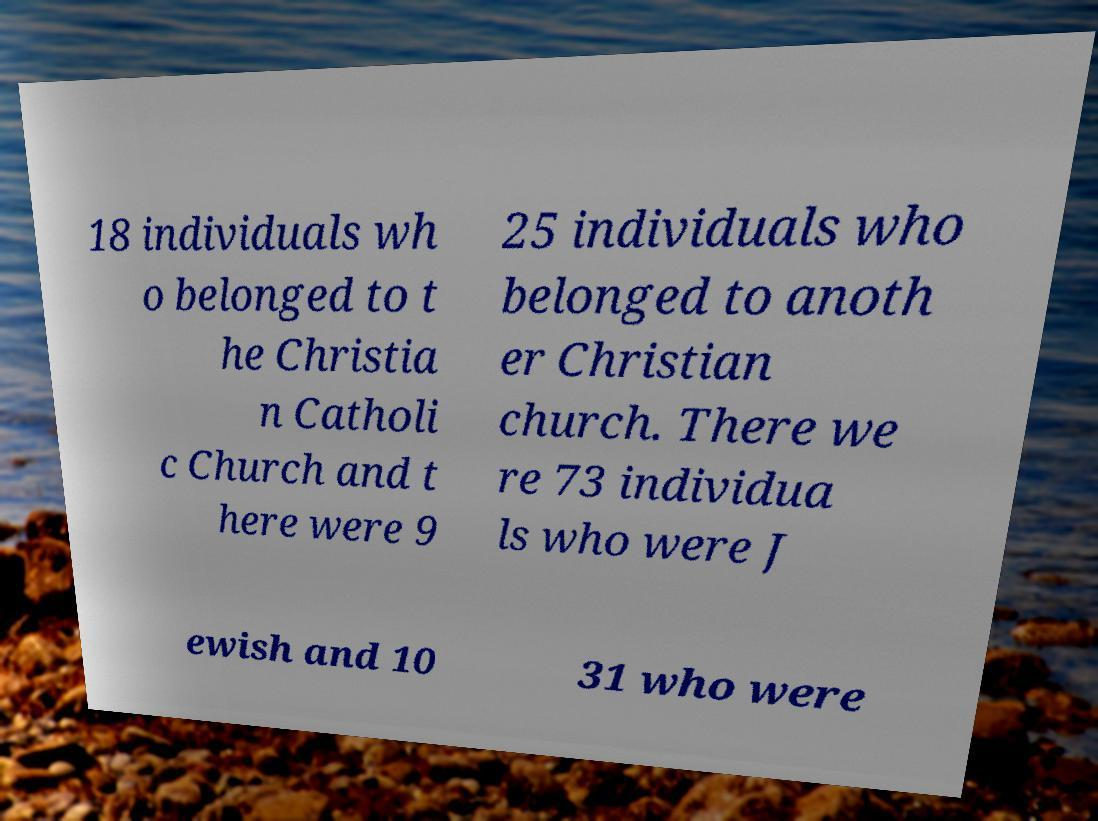Please read and relay the text visible in this image. What does it say? 18 individuals wh o belonged to t he Christia n Catholi c Church and t here were 9 25 individuals who belonged to anoth er Christian church. There we re 73 individua ls who were J ewish and 10 31 who were 